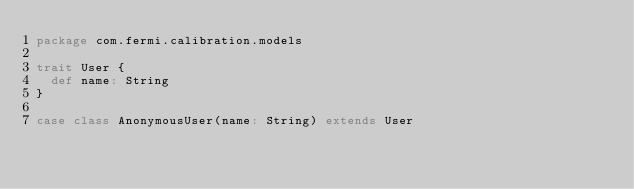Convert code to text. <code><loc_0><loc_0><loc_500><loc_500><_Scala_>package com.fermi.calibration.models

trait User {
  def name: String
}

case class AnonymousUser(name: String) extends User
</code> 